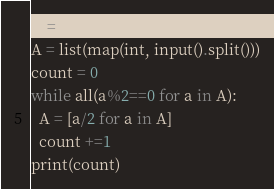Convert code to text. <code><loc_0><loc_0><loc_500><loc_500><_Python_>N = int(input())
A = list(map(int, input().split()))
count = 0
while all(a%2==0 for a in A):
  A = [a/2 for a in A]
  count +=1
print(count)</code> 